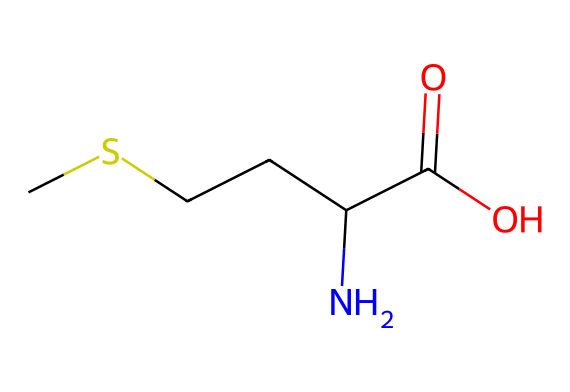What is the molecular formula of methionine? By examining the SMILES representation, one can see that there are 5 carbon (C) atoms, 11 hydrogen (H) atoms, 1 nitrogen (N) atom, and 2 oxygen (O) atoms, leading to the molecular formula C5H11NO2.
Answer: C5H11NO2 How many chiral centers are present in methionine? A chiral center is identified by a carbon atom bonded to four different substituents. In the case of methionine, there is one such carbon (the one bonded to the amino group, carboxyl group, and two other groups), indicating one chiral center.
Answer: 1 What type of functional group is present at the end of the methionine structure? The presence of the carboxylic acid moiety (indicated by C(=O)O) showcases the carboxyl functional group at one end of the molecule.
Answer: carboxylic acid Which elements present in the structure classify methionine as an organosulfur compound? The presence of the sulfur atom (S) in the structure distinguishes methionine as an organosulfur compound, as this class of compounds is characterized by containing sulfur in an organic framework.
Answer: sulfur What is the total number of hydrogen atoms in methionine? By counting the hydrogen atoms in the structure, including those bonded to carbon and nitrogen, there are a total of 11 hydrogen atoms in methionine as derived from the SMILES notation.
Answer: 11 What is the primary role of methionine in proteins? Methionine serves as an essential amino acid for protein synthesis and acts as a start codon in the genetic code (AUG), indicating its vital role in protein metabolism.
Answer: start codon 